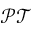Convert formula to latex. <formula><loc_0><loc_0><loc_500><loc_500>\mathcal { P T }</formula> 